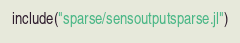Convert code to text. <code><loc_0><loc_0><loc_500><loc_500><_Julia_>include("sparse/sensoutputsparse.jl")</code> 